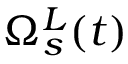Convert formula to latex. <formula><loc_0><loc_0><loc_500><loc_500>\Omega _ { s } ^ { L } ( t )</formula> 